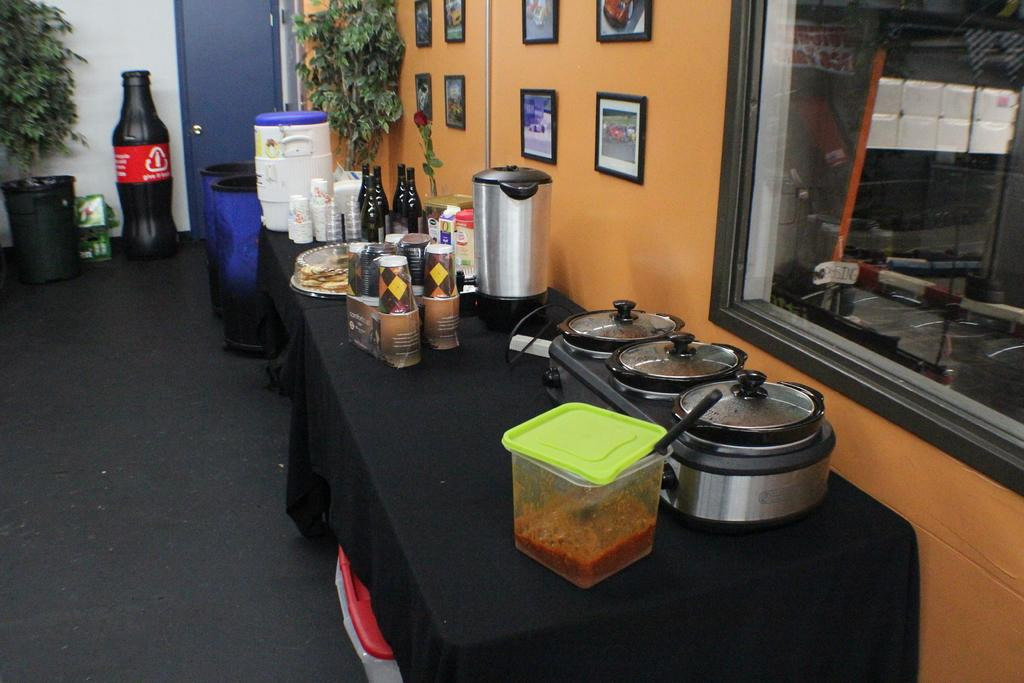<image>
Write a terse but informative summary of the picture. A soda-bottle shaped recycling container encourages people to "give it back." 